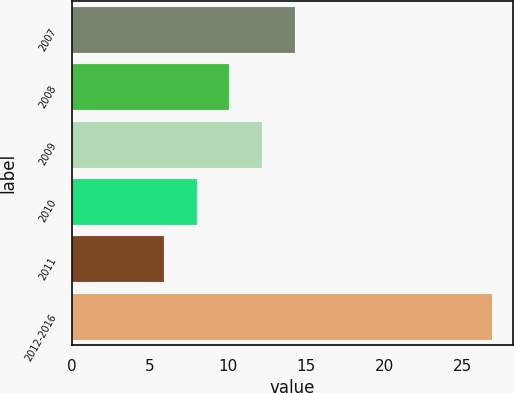Convert chart. <chart><loc_0><loc_0><loc_500><loc_500><bar_chart><fcel>2007<fcel>2008<fcel>2009<fcel>2010<fcel>2011<fcel>2012-2016<nl><fcel>14.3<fcel>10.1<fcel>12.2<fcel>8<fcel>5.9<fcel>26.9<nl></chart> 